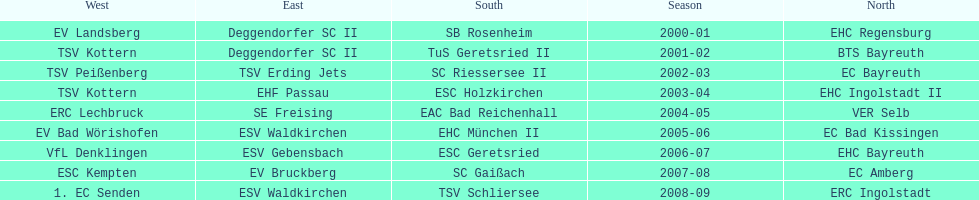Who won the south after esc geretsried did during the 2006-07 season? SC Gaißach. 